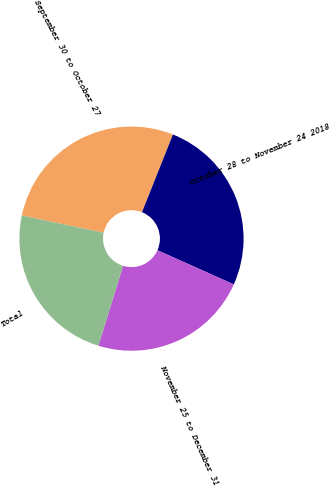Convert chart to OTSL. <chart><loc_0><loc_0><loc_500><loc_500><pie_chart><fcel>September 30 to October 27<fcel>October 28 to November 24 2018<fcel>November 25 to December 31<fcel>Total<nl><fcel>27.72%<fcel>25.66%<fcel>23.08%<fcel>23.54%<nl></chart> 